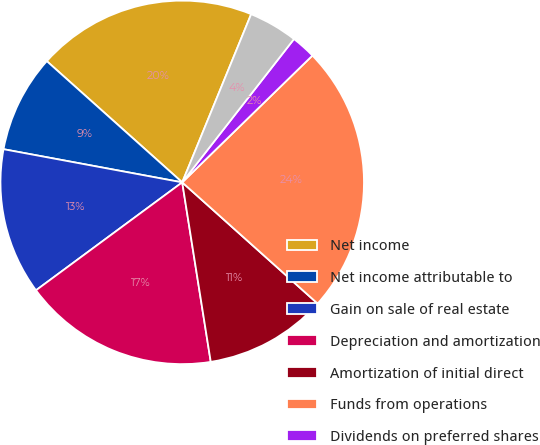Convert chart. <chart><loc_0><loc_0><loc_500><loc_500><pie_chart><fcel>Net income<fcel>Net income attributable to<fcel>Gain on sale of real estate<fcel>Depreciation and amortization<fcel>Amortization of initial direct<fcel>Funds from operations<fcel>Dividends on preferred shares<fcel>Income attributable to<nl><fcel>19.57%<fcel>8.7%<fcel>13.04%<fcel>17.39%<fcel>10.87%<fcel>23.91%<fcel>2.17%<fcel>4.35%<nl></chart> 